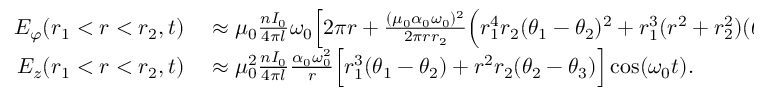Convert formula to latex. <formula><loc_0><loc_0><loc_500><loc_500>\begin{array} { r l } { E _ { \varphi } ( r _ { 1 } < r < r _ { 2 } , t ) } & \approx \mu _ { 0 } \frac { n I _ { 0 } } { 4 \pi l } \omega _ { 0 } \Big [ 2 \pi r + \frac { ( \mu _ { 0 } \alpha _ { 0 } \omega _ { 0 } ) ^ { 2 } } { 2 \pi r r _ { 2 } } \Big ( r _ { 1 } ^ { 4 } r _ { 2 } ( \theta _ { 1 } - \theta _ { 2 } ) ^ { 2 } + r _ { 1 } ^ { 3 } ( r ^ { 2 } + r _ { 2 } ^ { 2 } ) ( \theta _ { 1 } - \theta _ { 2 } ) ( \theta _ { 2 } - \theta _ { 3 } ) + r ^ { 2 } r _ { 2 } ^ { 3 } ( \theta _ { 2 } - \theta _ { 3 } ) ^ { 2 } \Big ) } \\ { E _ { z } ( r _ { 1 } < r < r _ { 2 } , t ) } & \approx \mu _ { 0 } ^ { 2 } \frac { n I _ { 0 } } { 4 \pi l } \frac { \alpha _ { 0 } \omega _ { 0 } ^ { 2 } } { r } \Big [ r _ { 1 } ^ { 3 } ( \theta _ { 1 } - \theta _ { 2 } ) + r ^ { 2 } r _ { 2 } ( \theta _ { 2 } - \theta _ { 3 } ) \Big ] \cos ( \omega _ { 0 } t ) . } \end{array}</formula> 